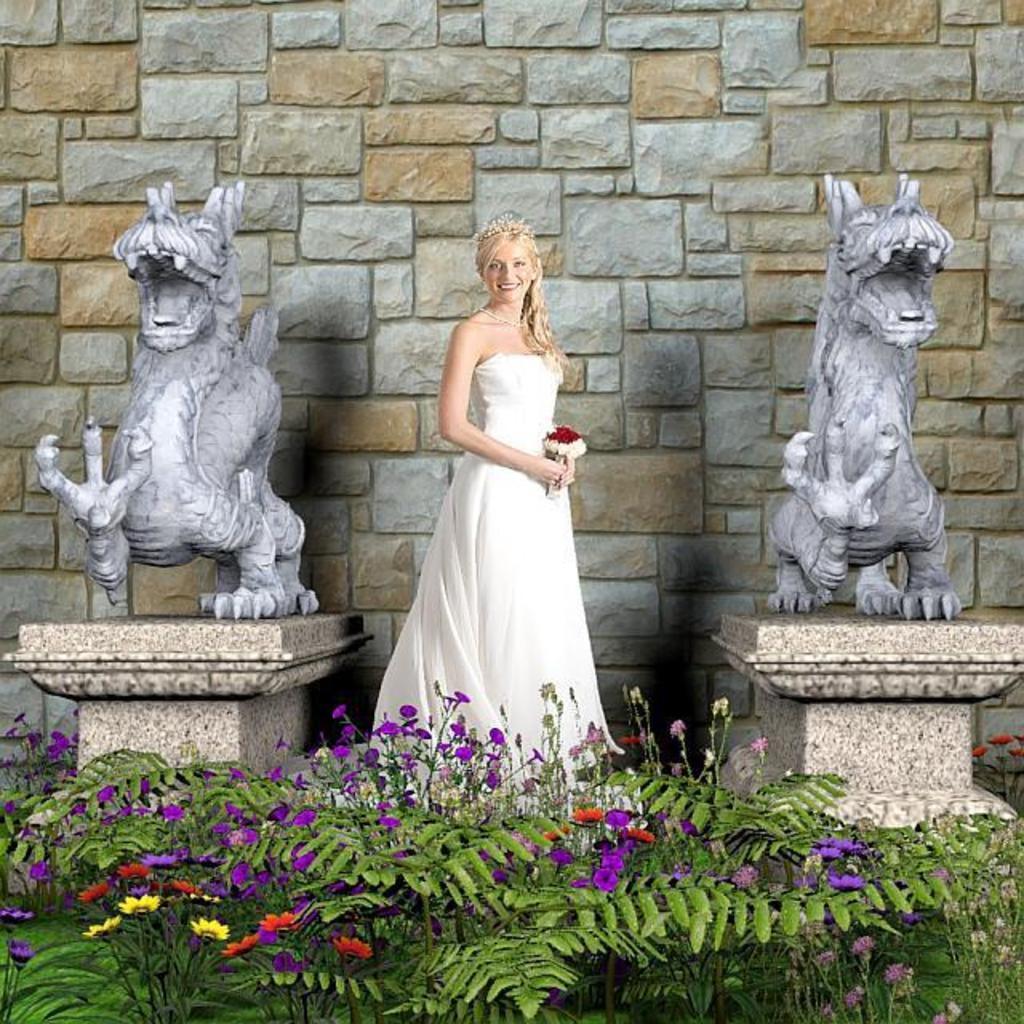In one or two sentences, can you explain what this image depicts? In the center of the image there is a person wearing a smile on her face and she is holding the flowers. Beside her there are statues. Behind her there is a wall. In front of her there are plants and flowers. 